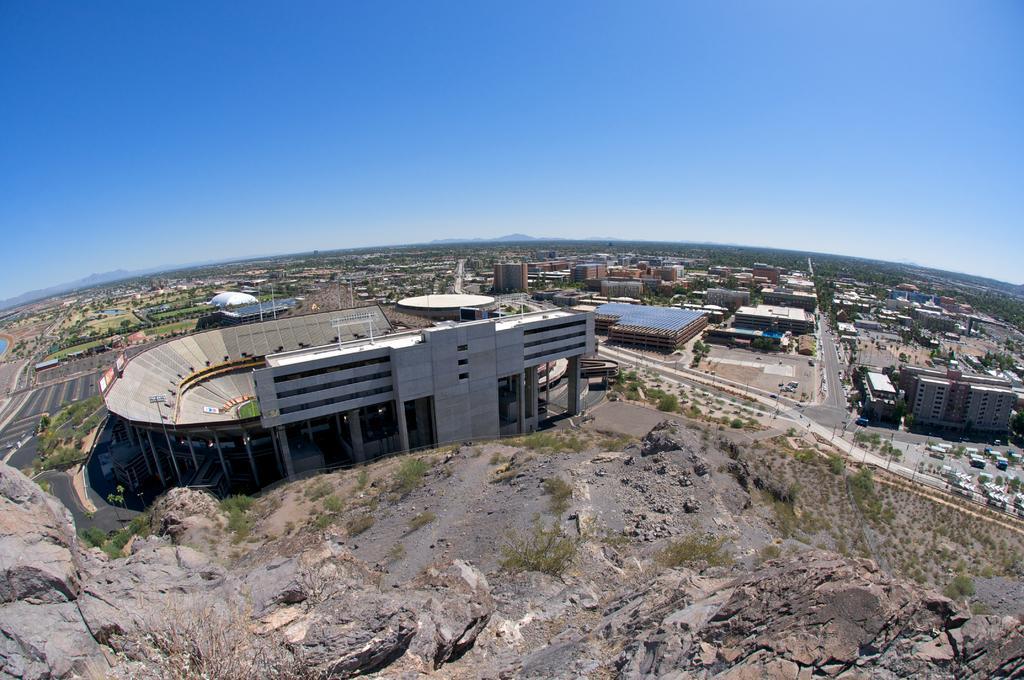How would you summarize this image in a sentence or two? In this image I can see a building, few trees, some grass, a mountain and in the background I can see few other buildings, few roads, few trees, few mountains and the sky. 